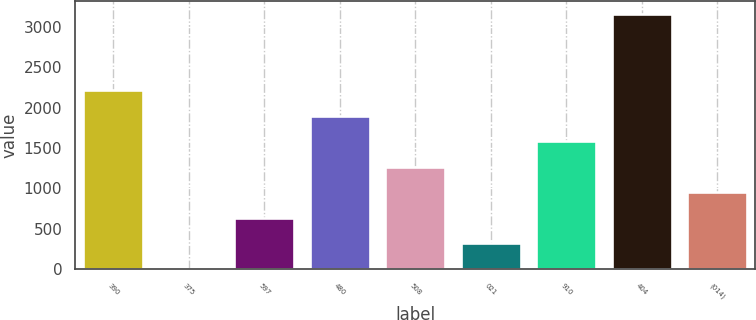Convert chart. <chart><loc_0><loc_0><loc_500><loc_500><bar_chart><fcel>390<fcel>375<fcel>597<fcel>480<fcel>508<fcel>021<fcel>910<fcel>404<fcel>(014)<nl><fcel>2214.57<fcel>3.85<fcel>635.49<fcel>1898.75<fcel>1267.12<fcel>319.67<fcel>1582.93<fcel>3162<fcel>951.31<nl></chart> 